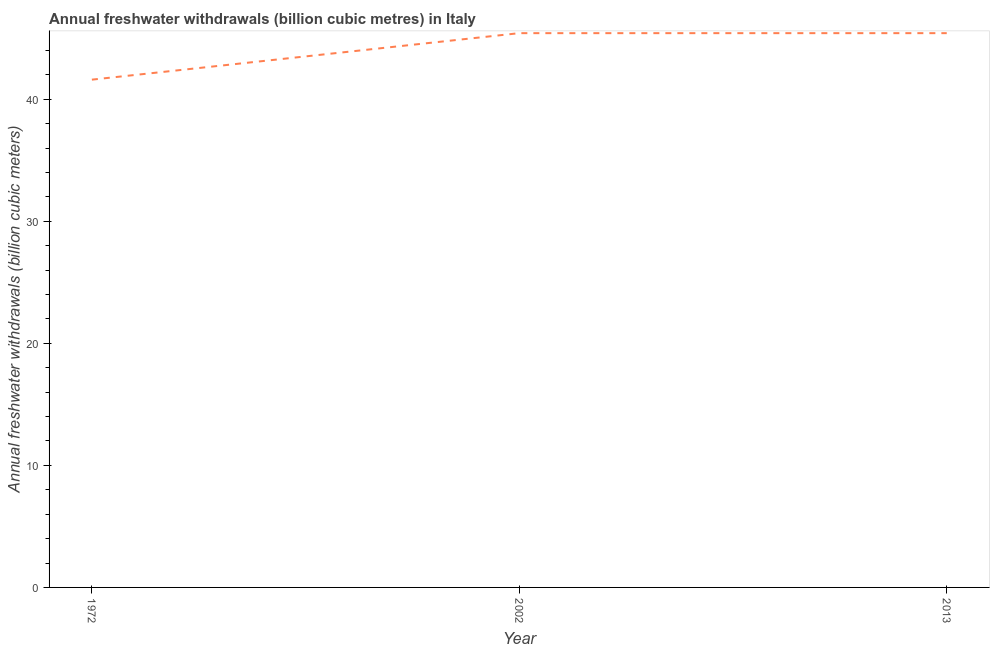What is the annual freshwater withdrawals in 2013?
Provide a short and direct response. 45.41. Across all years, what is the maximum annual freshwater withdrawals?
Your response must be concise. 45.41. Across all years, what is the minimum annual freshwater withdrawals?
Your response must be concise. 41.6. In which year was the annual freshwater withdrawals minimum?
Give a very brief answer. 1972. What is the sum of the annual freshwater withdrawals?
Your response must be concise. 132.42. What is the difference between the annual freshwater withdrawals in 1972 and 2013?
Your answer should be very brief. -3.81. What is the average annual freshwater withdrawals per year?
Provide a succinct answer. 44.14. What is the median annual freshwater withdrawals?
Provide a succinct answer. 45.41. In how many years, is the annual freshwater withdrawals greater than 22 billion cubic meters?
Provide a short and direct response. 3. What is the ratio of the annual freshwater withdrawals in 2002 to that in 2013?
Keep it short and to the point. 1. What is the difference between the highest and the second highest annual freshwater withdrawals?
Your response must be concise. 0. Is the sum of the annual freshwater withdrawals in 1972 and 2013 greater than the maximum annual freshwater withdrawals across all years?
Give a very brief answer. Yes. What is the difference between the highest and the lowest annual freshwater withdrawals?
Your answer should be compact. 3.81. In how many years, is the annual freshwater withdrawals greater than the average annual freshwater withdrawals taken over all years?
Make the answer very short. 2. Does the annual freshwater withdrawals monotonically increase over the years?
Make the answer very short. No. What is the difference between two consecutive major ticks on the Y-axis?
Your response must be concise. 10. Are the values on the major ticks of Y-axis written in scientific E-notation?
Offer a very short reply. No. Does the graph contain any zero values?
Make the answer very short. No. Does the graph contain grids?
Keep it short and to the point. No. What is the title of the graph?
Offer a terse response. Annual freshwater withdrawals (billion cubic metres) in Italy. What is the label or title of the X-axis?
Offer a very short reply. Year. What is the label or title of the Y-axis?
Provide a succinct answer. Annual freshwater withdrawals (billion cubic meters). What is the Annual freshwater withdrawals (billion cubic meters) of 1972?
Your answer should be very brief. 41.6. What is the Annual freshwater withdrawals (billion cubic meters) of 2002?
Your response must be concise. 45.41. What is the Annual freshwater withdrawals (billion cubic meters) in 2013?
Offer a very short reply. 45.41. What is the difference between the Annual freshwater withdrawals (billion cubic meters) in 1972 and 2002?
Offer a terse response. -3.81. What is the difference between the Annual freshwater withdrawals (billion cubic meters) in 1972 and 2013?
Make the answer very short. -3.81. What is the ratio of the Annual freshwater withdrawals (billion cubic meters) in 1972 to that in 2002?
Offer a terse response. 0.92. What is the ratio of the Annual freshwater withdrawals (billion cubic meters) in 1972 to that in 2013?
Your response must be concise. 0.92. What is the ratio of the Annual freshwater withdrawals (billion cubic meters) in 2002 to that in 2013?
Your answer should be compact. 1. 